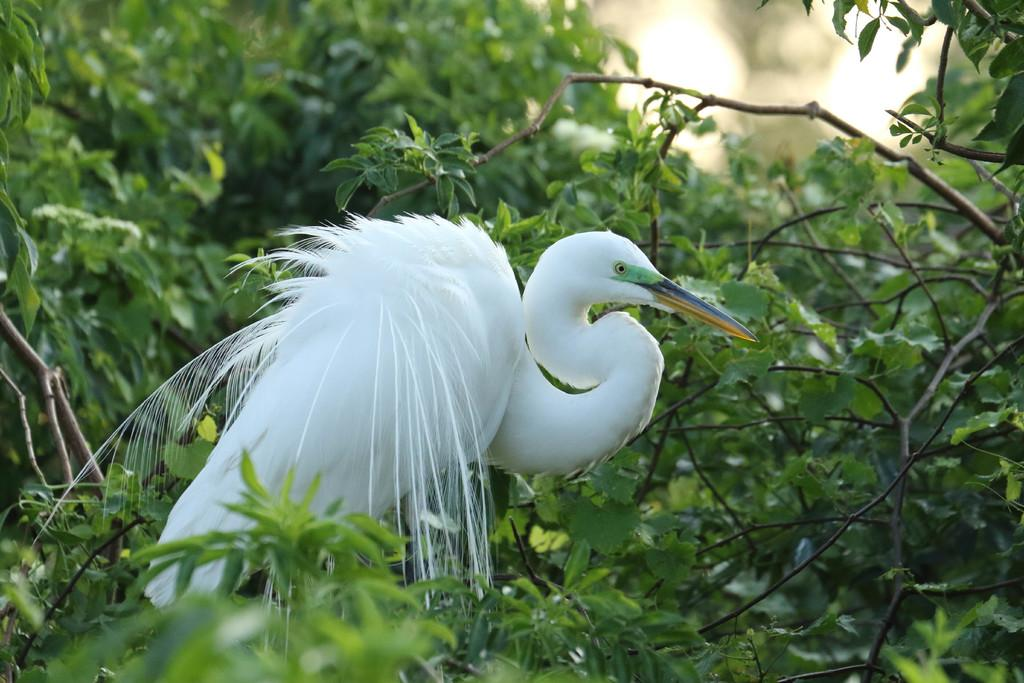What type of animal is in the image? There is a white bird in the image. What is a distinctive feature of the bird? The bird has a long beak. Where is the bird located in the image? The bird is standing on a branch of a tree. What can be seen in the background of the image? There are trees visible in the background of the image. What type of doll is being flown by the kite in the image? There is no doll or kite present in the image; it features a white bird standing on a tree branch. 